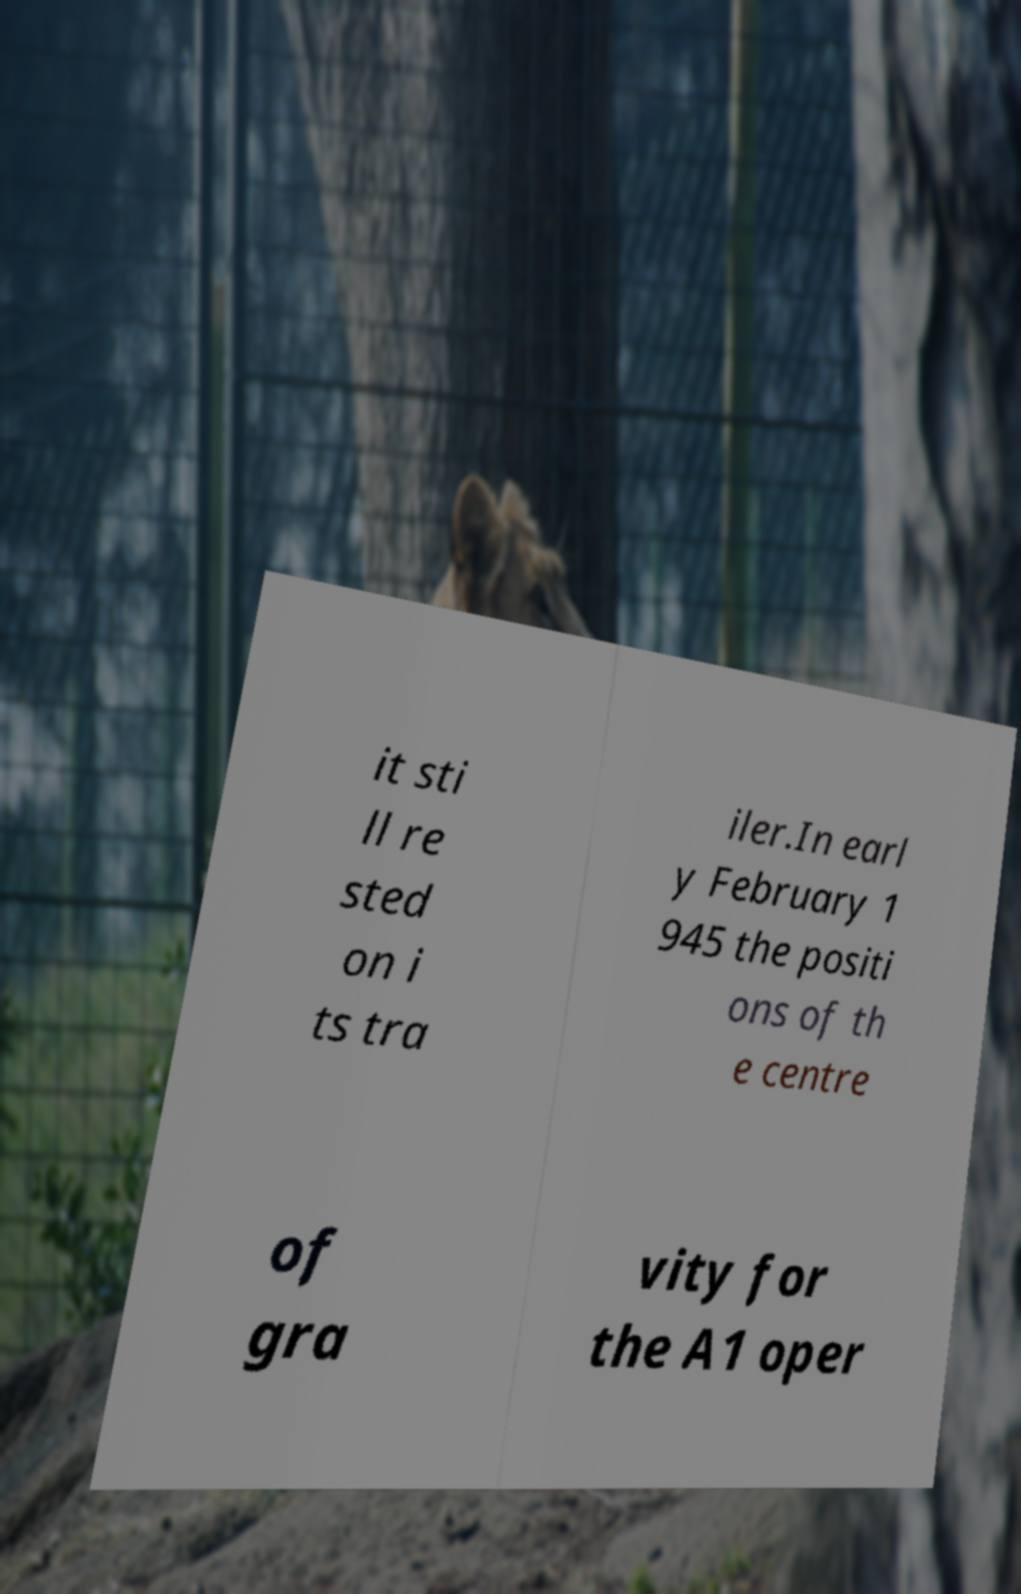Can you read and provide the text displayed in the image?This photo seems to have some interesting text. Can you extract and type it out for me? it sti ll re sted on i ts tra iler.In earl y February 1 945 the positi ons of th e centre of gra vity for the A1 oper 